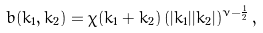Convert formula to latex. <formula><loc_0><loc_0><loc_500><loc_500>b ( { k } _ { 1 } , { k } _ { 2 } ) = \chi ( { k } _ { 1 } + { k } _ { 2 } ) \, ( | { k } _ { 1 } | | { k } _ { 2 } | ) ^ { \nu - \frac { 1 } { 2 } } \, ,</formula> 